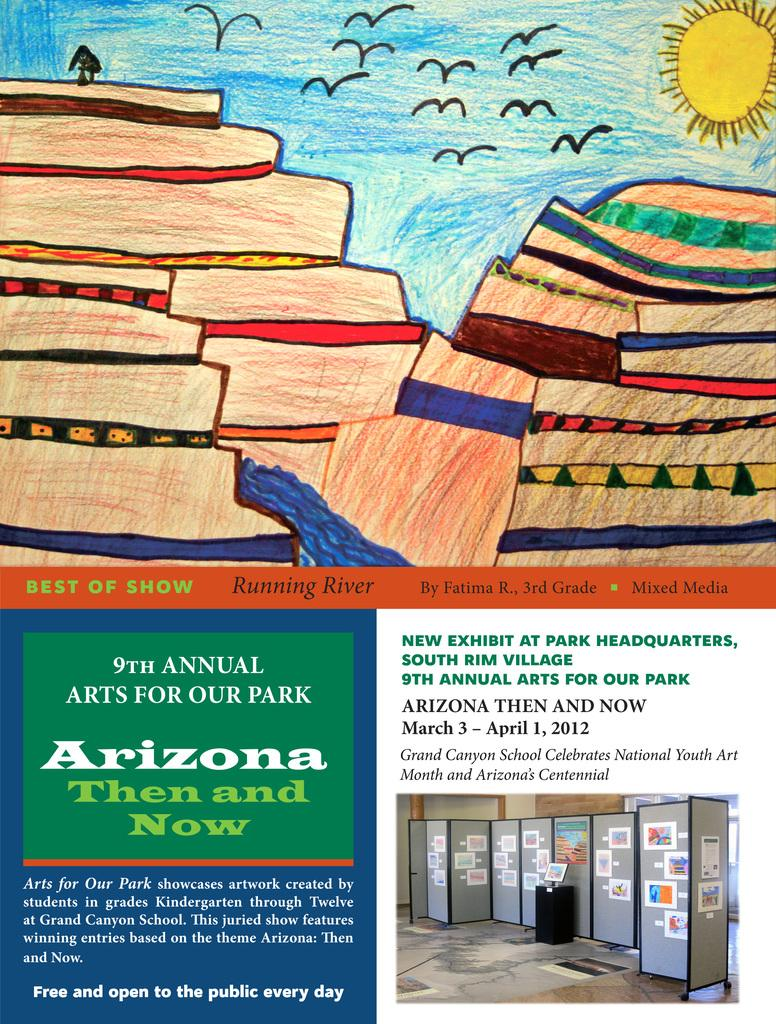<image>
Summarize the visual content of the image. The cover of an info page for an arizona then and now art show. 